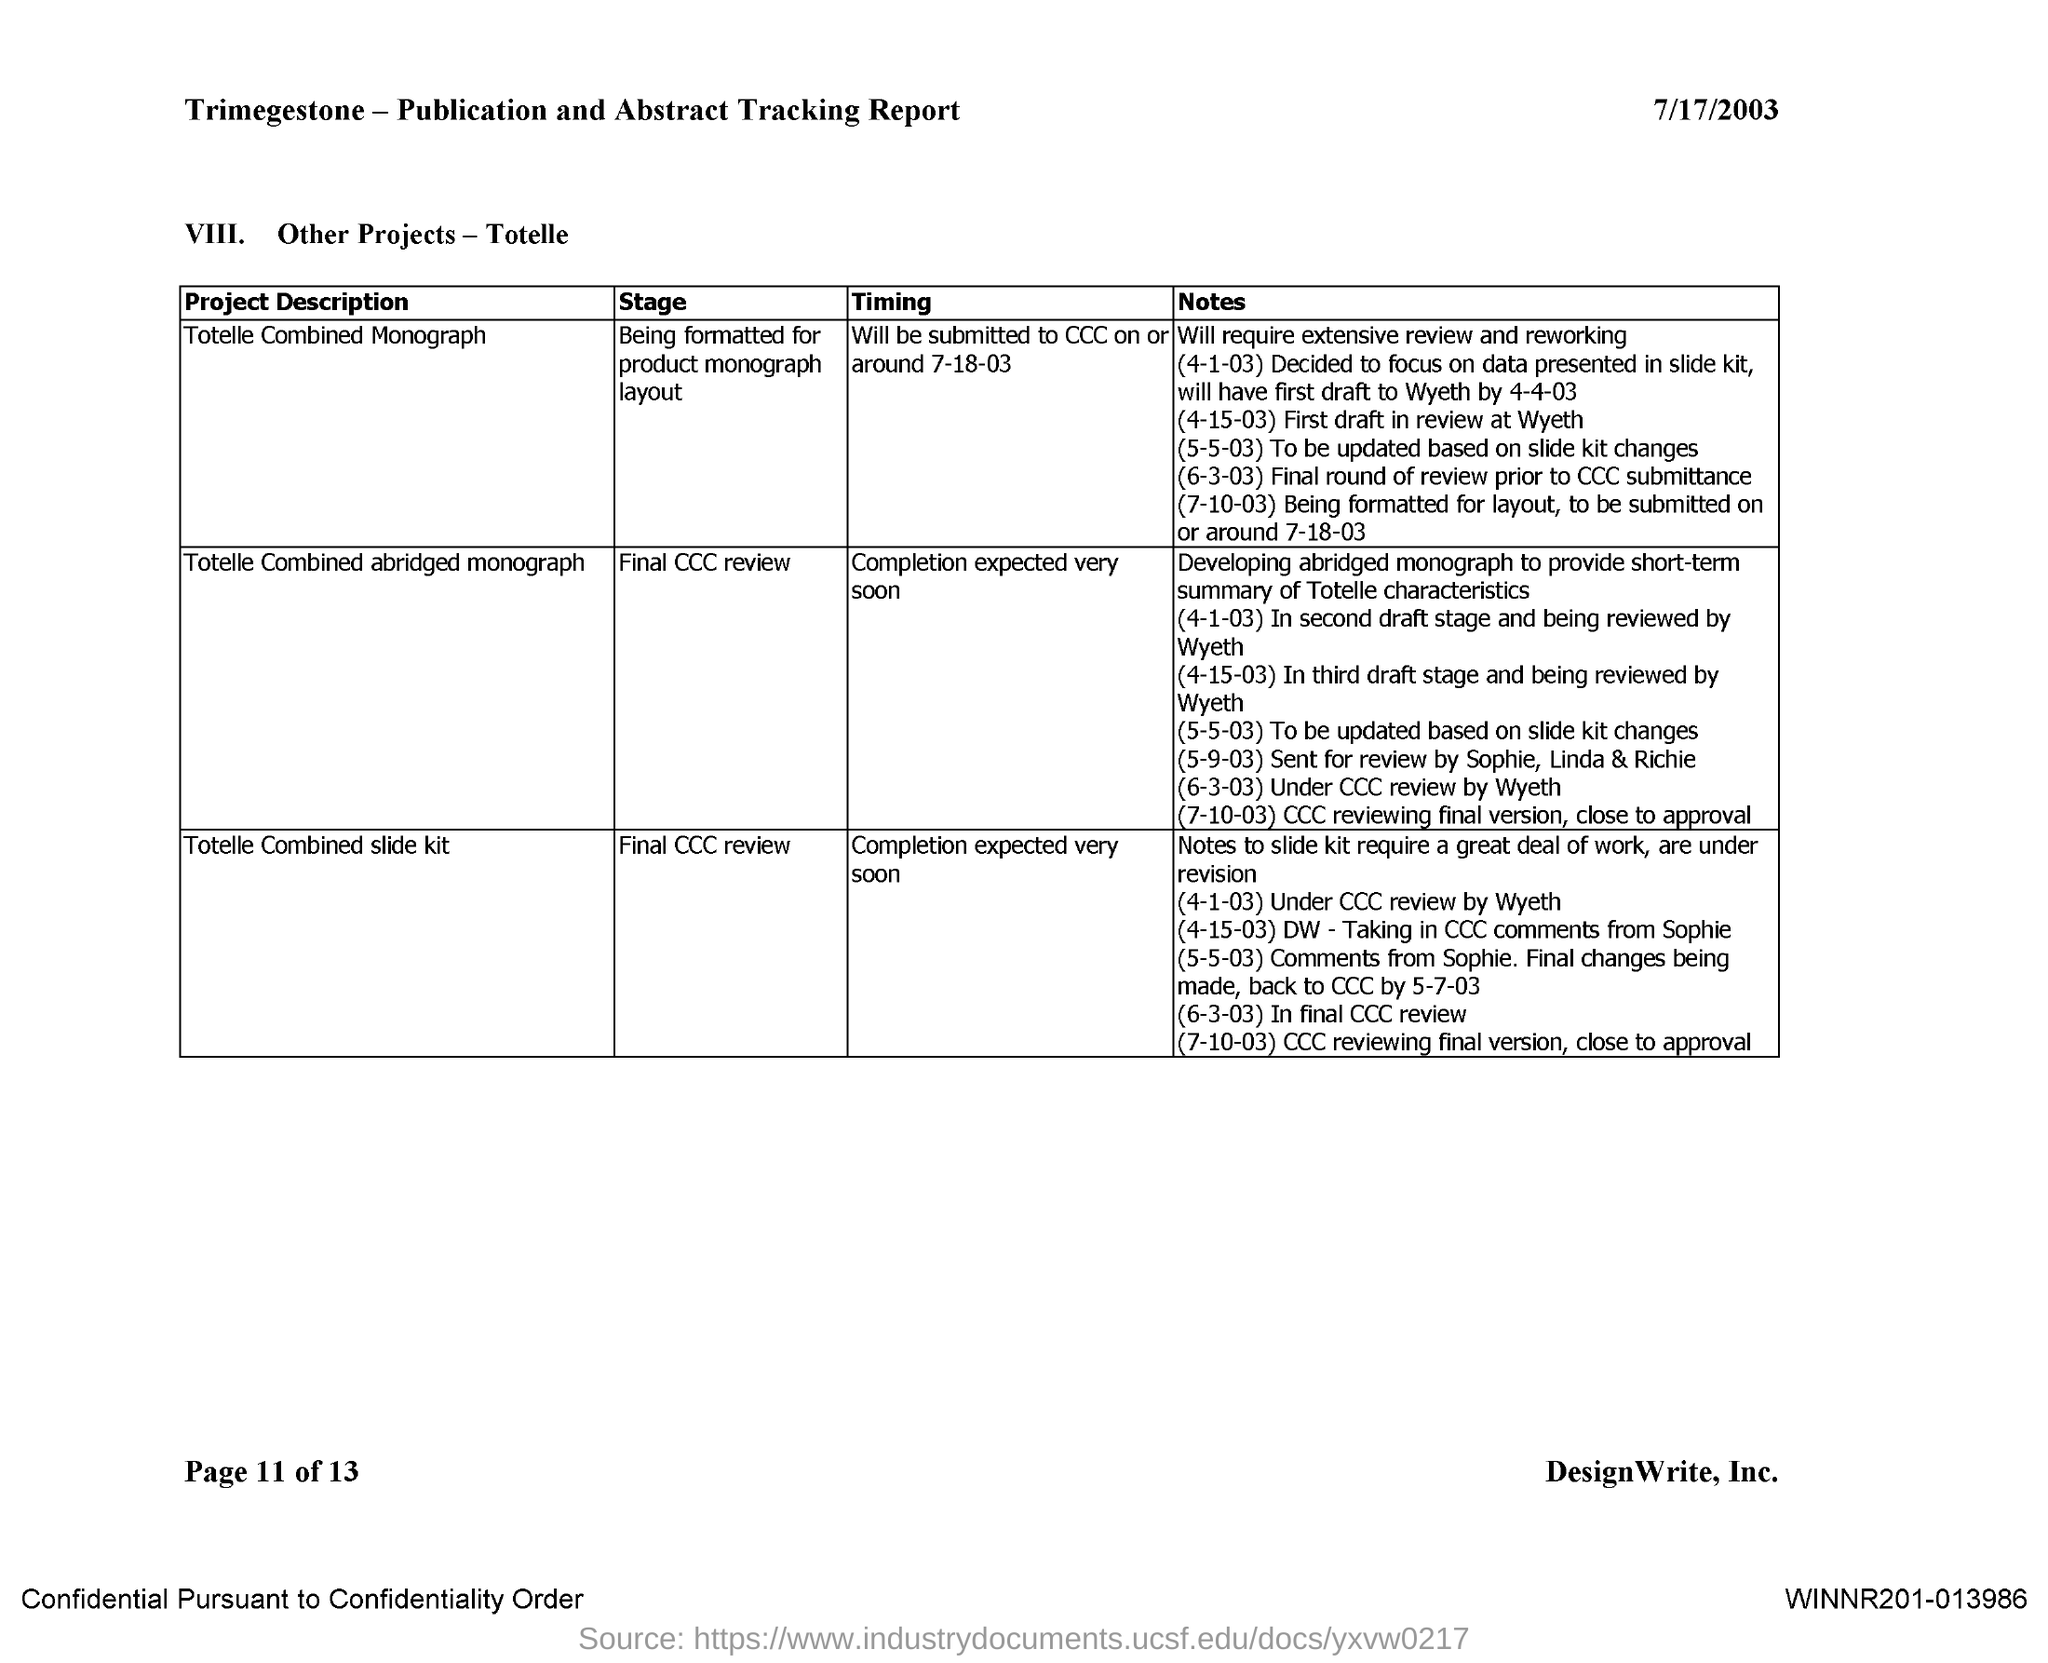Highlight a few significant elements in this photo. The date mentioned in the document is 7/17/2003. 